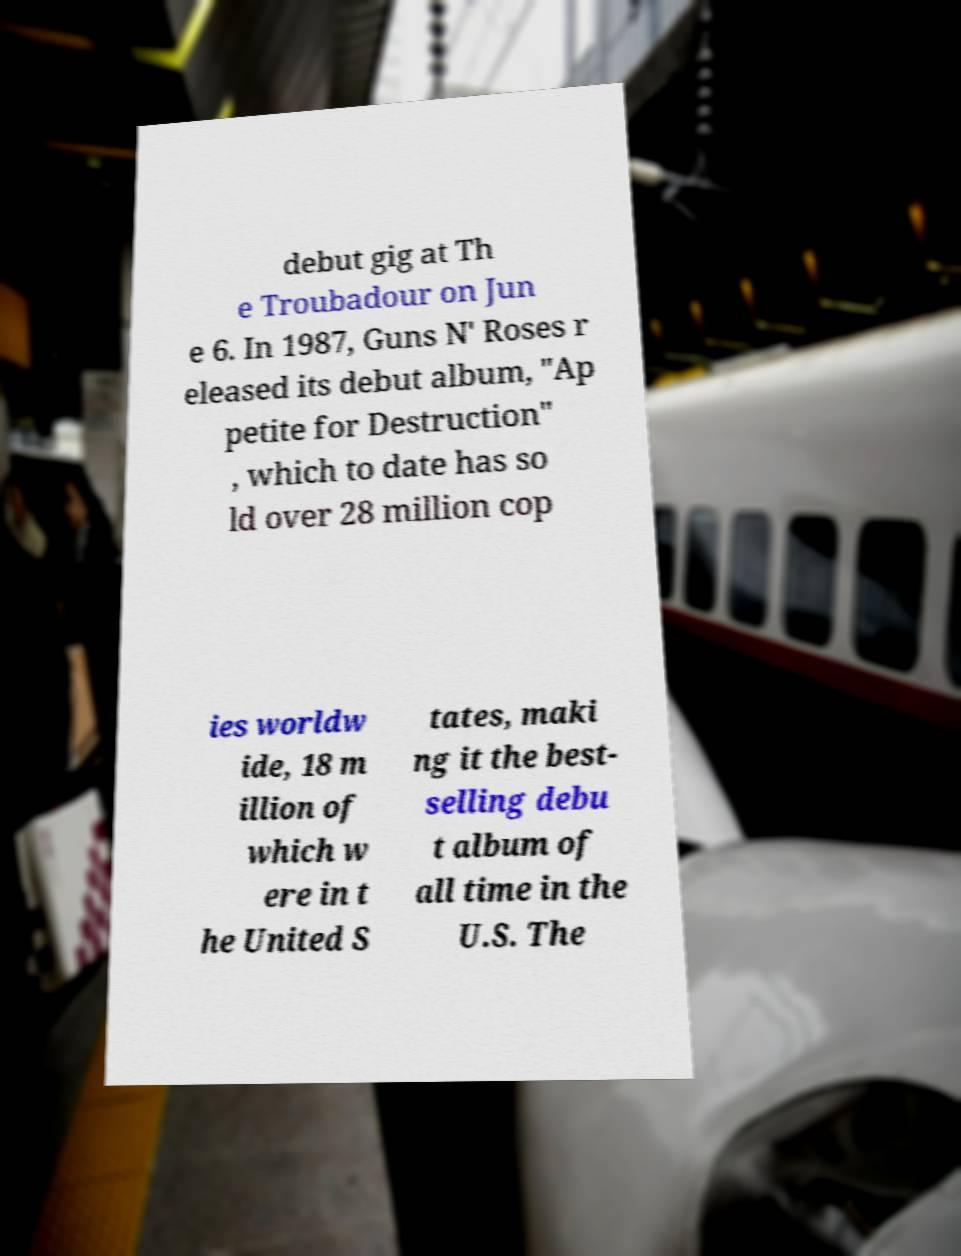Can you read and provide the text displayed in the image?This photo seems to have some interesting text. Can you extract and type it out for me? debut gig at Th e Troubadour on Jun e 6. In 1987, Guns N' Roses r eleased its debut album, "Ap petite for Destruction" , which to date has so ld over 28 million cop ies worldw ide, 18 m illion of which w ere in t he United S tates, maki ng it the best- selling debu t album of all time in the U.S. The 